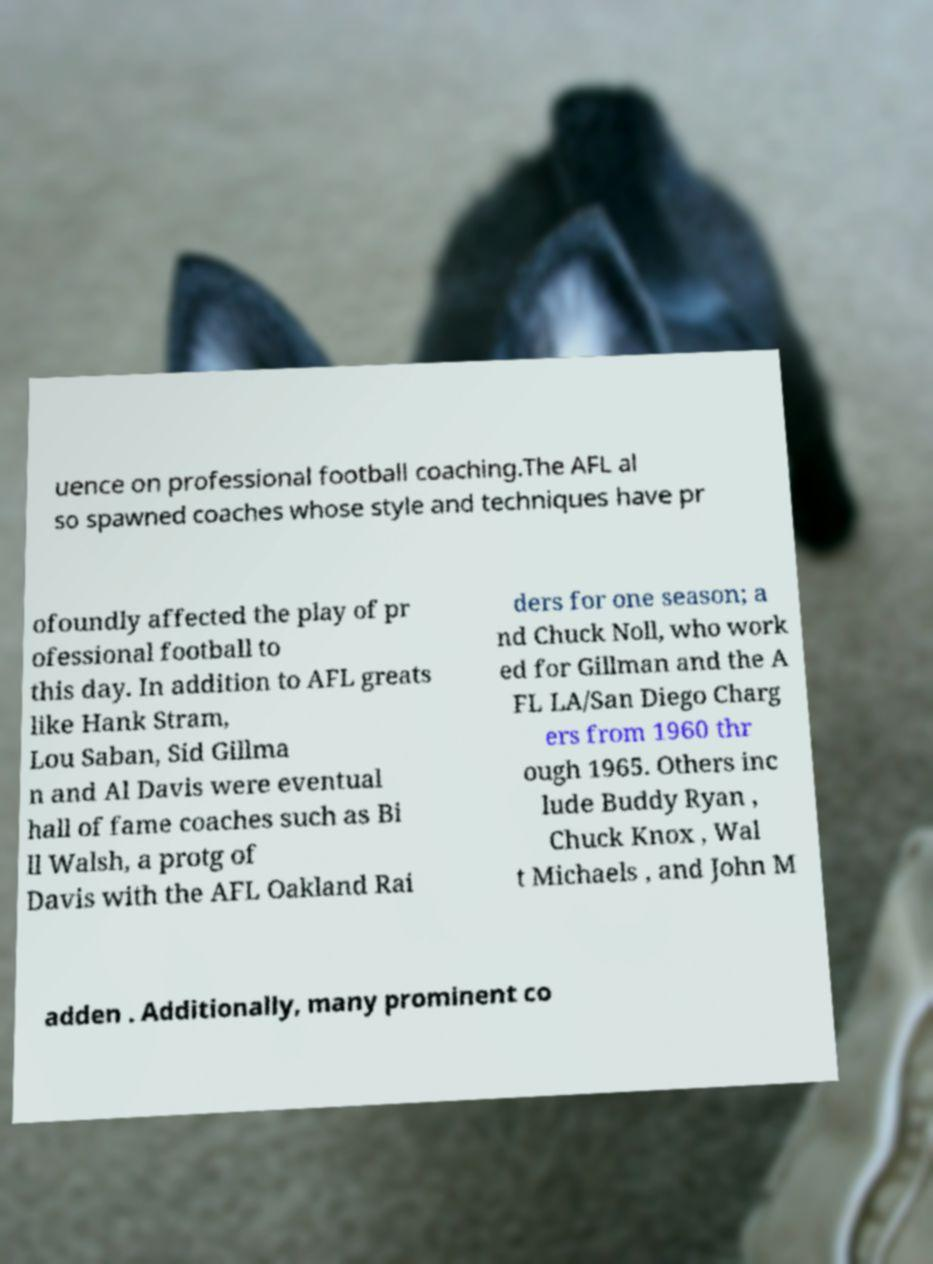What messages or text are displayed in this image? I need them in a readable, typed format. uence on professional football coaching.The AFL al so spawned coaches whose style and techniques have pr ofoundly affected the play of pr ofessional football to this day. In addition to AFL greats like Hank Stram, Lou Saban, Sid Gillma n and Al Davis were eventual hall of fame coaches such as Bi ll Walsh, a protg of Davis with the AFL Oakland Rai ders for one season; a nd Chuck Noll, who work ed for Gillman and the A FL LA/San Diego Charg ers from 1960 thr ough 1965. Others inc lude Buddy Ryan , Chuck Knox , Wal t Michaels , and John M adden . Additionally, many prominent co 